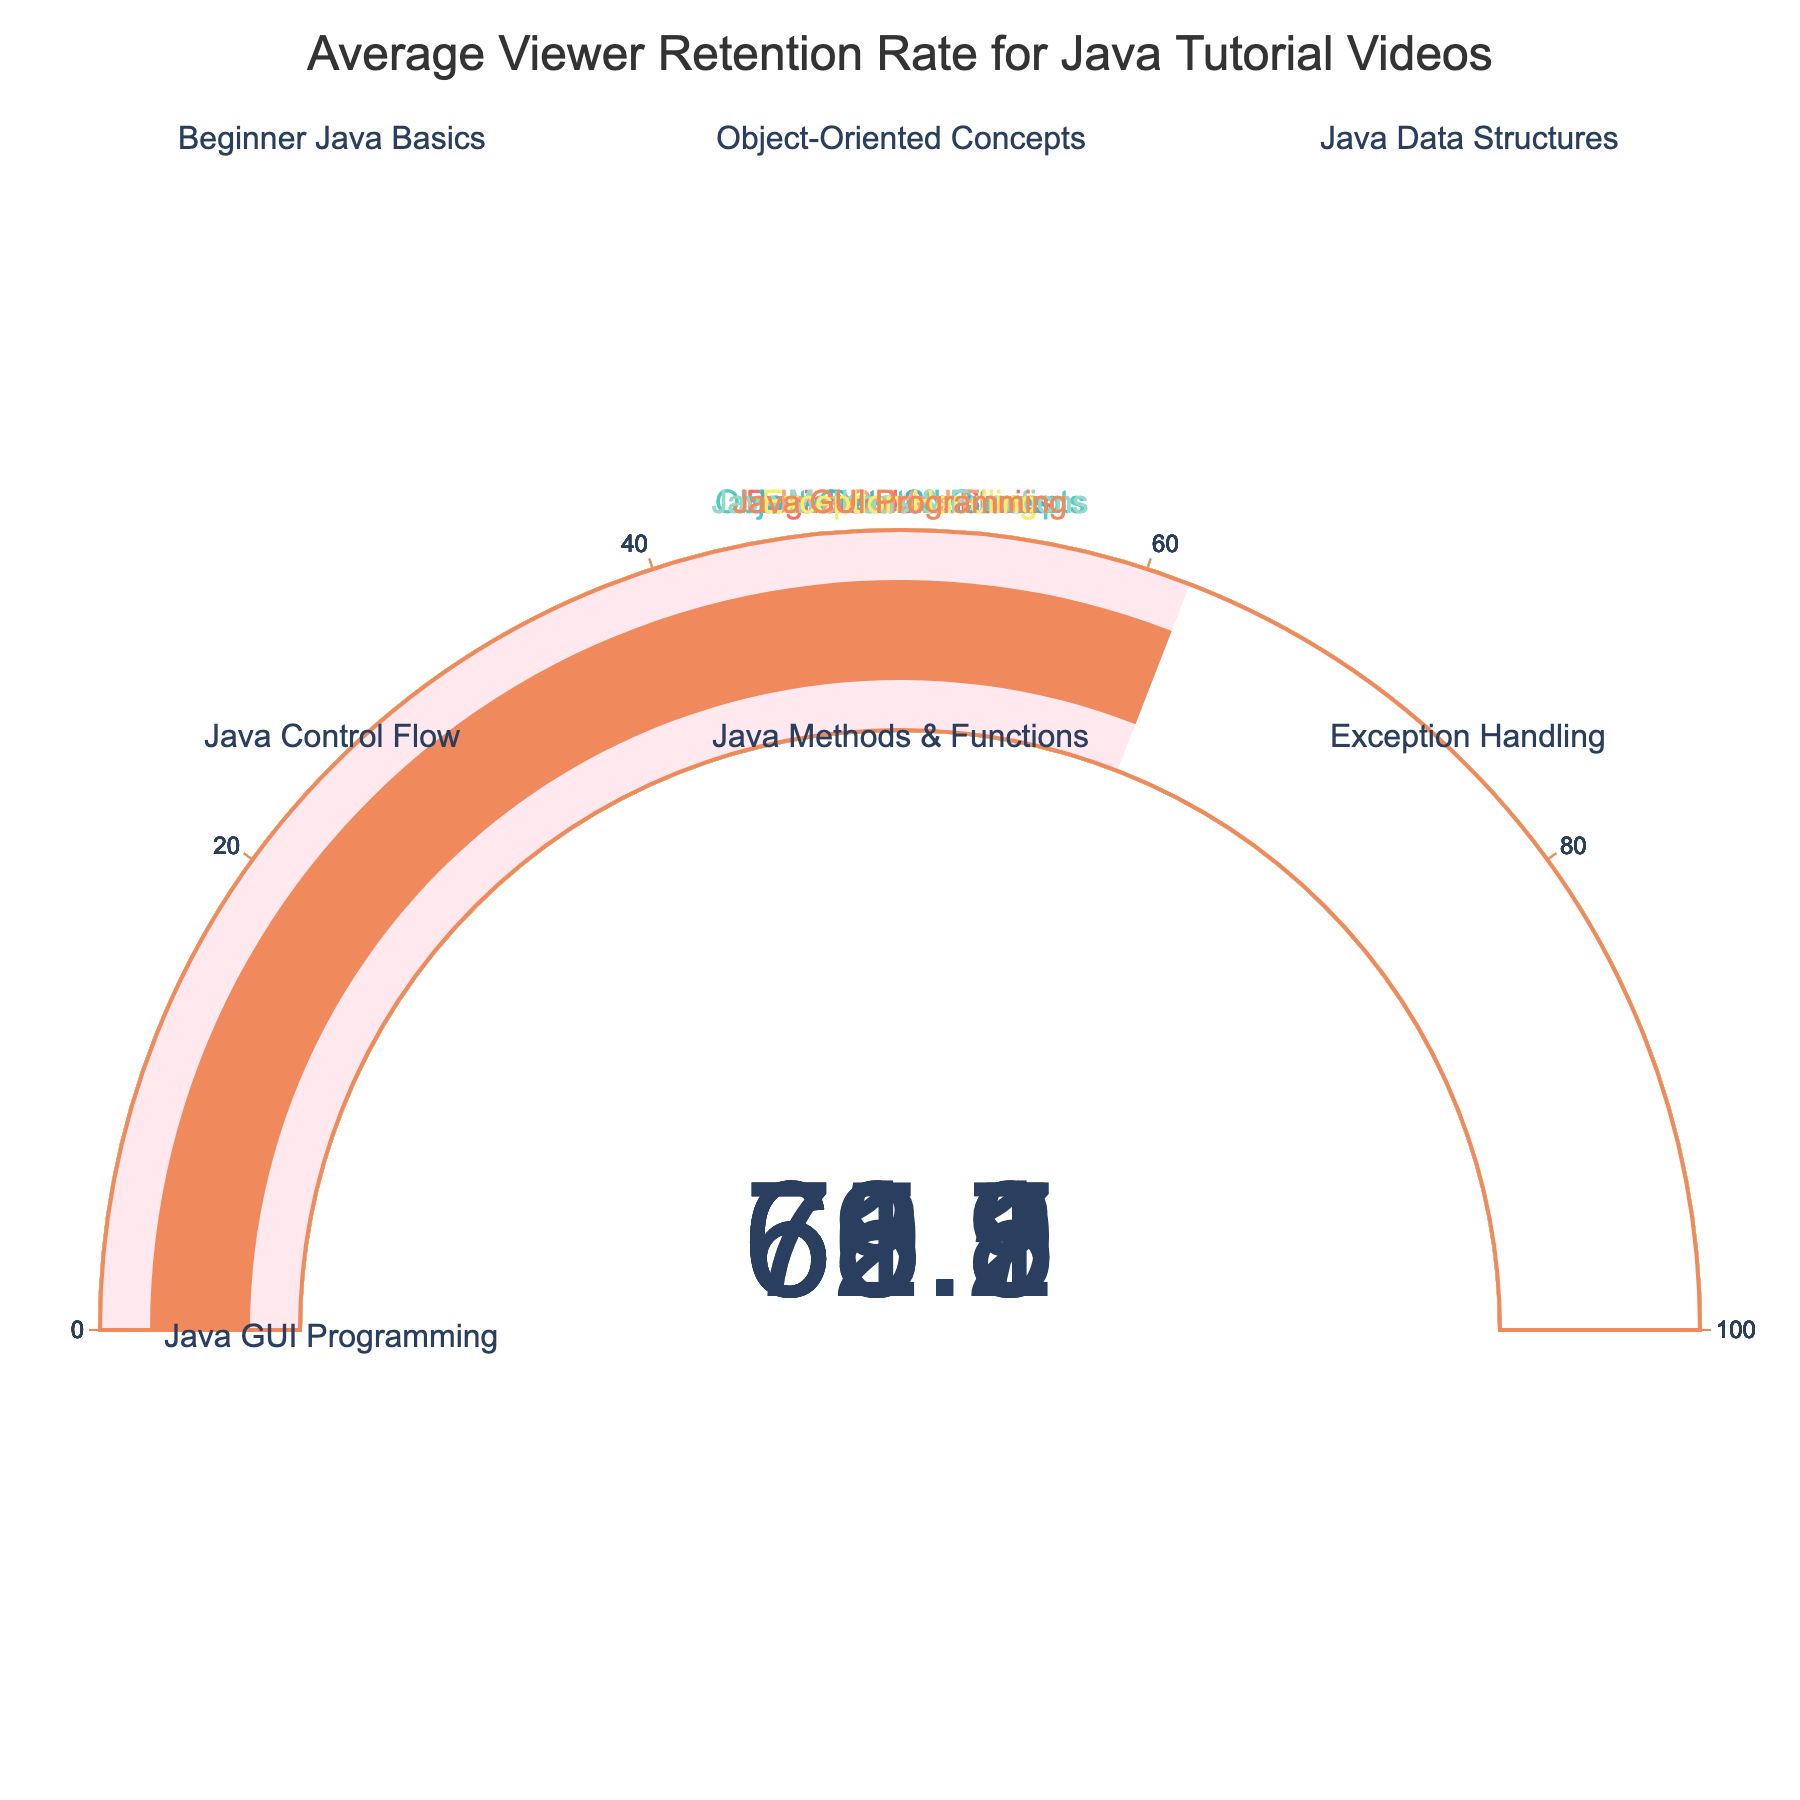What's the title of the chart? The title of the chart is usually at the top, clearly stating the main topic covered in the figure. In this case, the title reads, "Average Viewer Retention Rate for Java Tutorial Videos."
Answer: Average Viewer Retention Rate for Java Tutorial Videos Which video has the highest viewer retention rate? By examining the gauge charts, we can see the retention rates displayed for each video. The gauge titled "Beginner Java Basics" shows the highest retention rate of 72.5%.
Answer: Beginner Java Basics What are the retention rates for the "Java Data Structures" and "Java GUI Programming" videos? Based on the figure, we can see the gauge values for each video title. "Java Data Structures" has a retention rate of 65.9%, and "Java GUI Programming" has a retention rate of 61.8%.
Answer: 65.9% and 61.8% What is the average retention rate for all the videos combined? To find the average retention rate, we add all the individual retention rates and divide by the number of videos: (72.5 + 68.3 + 65.9 + 70.1 + 69.7 + 63.2 + 61.8) / 7 = 471.5 / 7 ≈ 67.36%.
Answer: Approximately 67.36% Which video has a lower retention rate: "Java Control Flow" or "Java Methods & Functions"? Looking at the values on the gauges, "Java Control Flow" shows a retention rate of 70.1%, while "Java Methods & Functions" shows a rate of 69.7%. Since 69.7% < 70.1%, "Java Methods & Functions" has the lower retention rate.
Answer: Java Methods & Functions How much greater is the retention rate for "Beginner Java Basics" compared to "Exception Handling"? Subtract the retention rate of "Exception Handling" from that of "Beginner Java Basics": 72.5% - 63.2% = 9.3%.
Answer: 9.3% What's the median retention rate of the listed Java tutorial videos? To find the median, we first arrange the retention rates in ascending order: 61.8%, 63.2%, 65.9%, 68.3%, 69.7%, 70.1%, 72.5%. With 7 values, the median is the middle value, which is 68.3%.
Answer: 68.3% Which video has the smallest viewer retention rate? The gauge showing the smallest retention rate is "Java GUI Programming" with a value of 61.8%.
Answer: Java GUI Programming If we create a new category by combining retention rates of "Object-Oriented Concepts" and "Java Data Structures," what would their combined average retention rate be? To find the combined average, we add the retention rates of both videos and divide by 2: (68.3% + 65.9%) / 2 = 67.1%.
Answer: 67.1% What are the colors used for the gauge charts in the figure? The colors used for the gauge charts correspond to the unique shades for each title in the figure and include: red, teal, blue, orange, green, yellow, and peach. Specifically, Beginner Java Basics (red), Object-Oriented Concepts (teal), Java Data Structures (blue), Java Control Flow (orange), Java Methods & Functions (green), Exception Handling (yellow), and Java GUI Programming (peach).
Answer: Red, teal, blue, orange, green, yellow, peach 